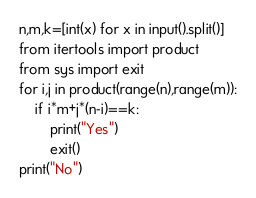Convert code to text. <code><loc_0><loc_0><loc_500><loc_500><_Python_>n,m,k=[int(x) for x in input().split()]
from itertools import product
from sys import exit
for i,j in product(range(n),range(m)):
    if i*m+j*(n-i)==k:
        print("Yes")
        exit()
print("No")</code> 